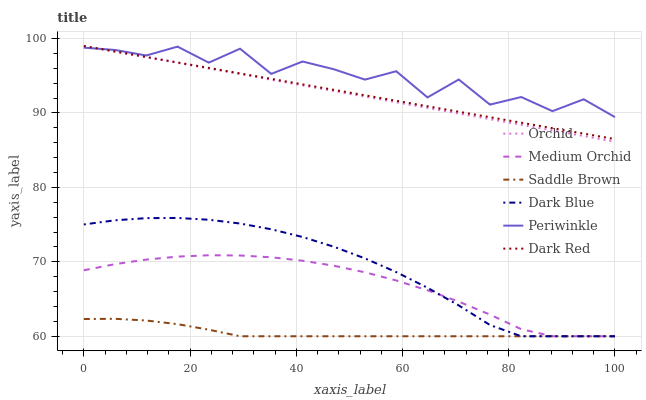Does Saddle Brown have the minimum area under the curve?
Answer yes or no. Yes. Does Periwinkle have the maximum area under the curve?
Answer yes or no. Yes. Does Medium Orchid have the minimum area under the curve?
Answer yes or no. No. Does Medium Orchid have the maximum area under the curve?
Answer yes or no. No. Is Orchid the smoothest?
Answer yes or no. Yes. Is Periwinkle the roughest?
Answer yes or no. Yes. Is Medium Orchid the smoothest?
Answer yes or no. No. Is Medium Orchid the roughest?
Answer yes or no. No. Does Medium Orchid have the lowest value?
Answer yes or no. Yes. Does Periwinkle have the lowest value?
Answer yes or no. No. Does Orchid have the highest value?
Answer yes or no. Yes. Does Medium Orchid have the highest value?
Answer yes or no. No. Is Medium Orchid less than Orchid?
Answer yes or no. Yes. Is Periwinkle greater than Saddle Brown?
Answer yes or no. Yes. Does Dark Red intersect Orchid?
Answer yes or no. Yes. Is Dark Red less than Orchid?
Answer yes or no. No. Is Dark Red greater than Orchid?
Answer yes or no. No. Does Medium Orchid intersect Orchid?
Answer yes or no. No. 